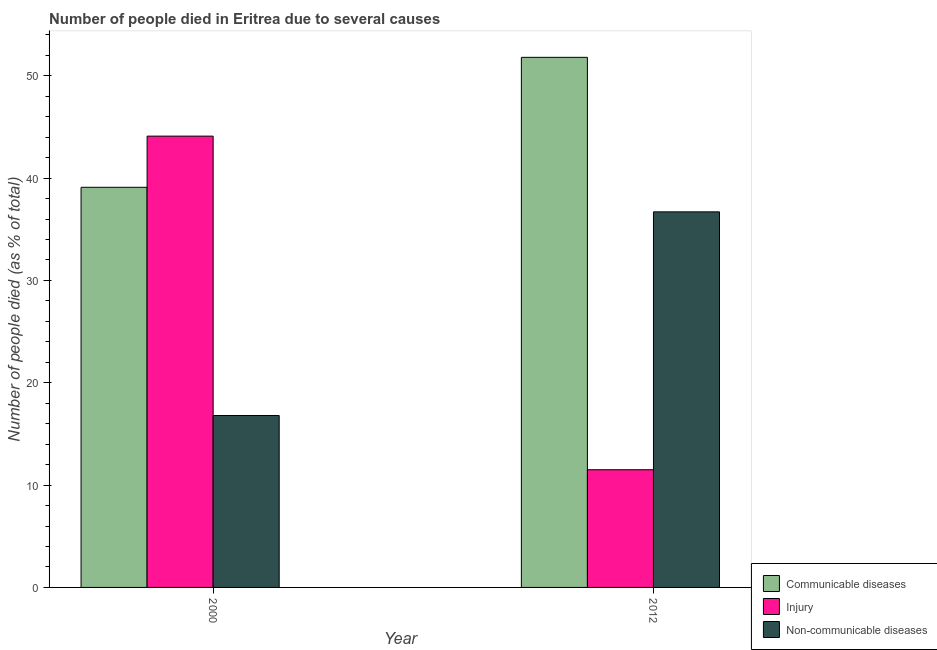How many bars are there on the 2nd tick from the right?
Provide a short and direct response. 3. Across all years, what is the maximum number of people who dies of non-communicable diseases?
Make the answer very short. 36.7. In which year was the number of people who dies of non-communicable diseases maximum?
Provide a short and direct response. 2012. In which year was the number of people who died of injury minimum?
Your answer should be compact. 2012. What is the total number of people who dies of non-communicable diseases in the graph?
Your response must be concise. 53.5. What is the difference between the number of people who died of communicable diseases in 2000 and that in 2012?
Your response must be concise. -12.7. What is the difference between the number of people who dies of non-communicable diseases in 2000 and the number of people who died of injury in 2012?
Your answer should be compact. -19.9. What is the average number of people who died of communicable diseases per year?
Keep it short and to the point. 45.45. In the year 2000, what is the difference between the number of people who died of injury and number of people who dies of non-communicable diseases?
Your answer should be very brief. 0. What is the ratio of the number of people who died of communicable diseases in 2000 to that in 2012?
Your response must be concise. 0.75. Is the number of people who dies of non-communicable diseases in 2000 less than that in 2012?
Your response must be concise. Yes. In how many years, is the number of people who died of injury greater than the average number of people who died of injury taken over all years?
Keep it short and to the point. 1. What does the 2nd bar from the left in 2012 represents?
Your answer should be very brief. Injury. What does the 2nd bar from the right in 2000 represents?
Make the answer very short. Injury. Is it the case that in every year, the sum of the number of people who died of communicable diseases and number of people who died of injury is greater than the number of people who dies of non-communicable diseases?
Give a very brief answer. Yes. How many years are there in the graph?
Provide a succinct answer. 2. What is the difference between two consecutive major ticks on the Y-axis?
Your response must be concise. 10. Does the graph contain grids?
Your answer should be very brief. No. Where does the legend appear in the graph?
Give a very brief answer. Bottom right. What is the title of the graph?
Ensure brevity in your answer.  Number of people died in Eritrea due to several causes. What is the label or title of the Y-axis?
Make the answer very short. Number of people died (as % of total). What is the Number of people died (as % of total) of Communicable diseases in 2000?
Ensure brevity in your answer.  39.1. What is the Number of people died (as % of total) in Injury in 2000?
Your answer should be compact. 44.1. What is the Number of people died (as % of total) of Non-communicable diseases in 2000?
Ensure brevity in your answer.  16.8. What is the Number of people died (as % of total) of Communicable diseases in 2012?
Make the answer very short. 51.8. What is the Number of people died (as % of total) in Injury in 2012?
Provide a succinct answer. 11.5. What is the Number of people died (as % of total) of Non-communicable diseases in 2012?
Keep it short and to the point. 36.7. Across all years, what is the maximum Number of people died (as % of total) in Communicable diseases?
Offer a terse response. 51.8. Across all years, what is the maximum Number of people died (as % of total) of Injury?
Keep it short and to the point. 44.1. Across all years, what is the maximum Number of people died (as % of total) in Non-communicable diseases?
Your answer should be very brief. 36.7. Across all years, what is the minimum Number of people died (as % of total) in Communicable diseases?
Your response must be concise. 39.1. Across all years, what is the minimum Number of people died (as % of total) of Injury?
Your answer should be very brief. 11.5. Across all years, what is the minimum Number of people died (as % of total) in Non-communicable diseases?
Your answer should be compact. 16.8. What is the total Number of people died (as % of total) in Communicable diseases in the graph?
Your answer should be compact. 90.9. What is the total Number of people died (as % of total) in Injury in the graph?
Keep it short and to the point. 55.6. What is the total Number of people died (as % of total) of Non-communicable diseases in the graph?
Offer a terse response. 53.5. What is the difference between the Number of people died (as % of total) in Communicable diseases in 2000 and that in 2012?
Your response must be concise. -12.7. What is the difference between the Number of people died (as % of total) in Injury in 2000 and that in 2012?
Provide a short and direct response. 32.6. What is the difference between the Number of people died (as % of total) of Non-communicable diseases in 2000 and that in 2012?
Your response must be concise. -19.9. What is the difference between the Number of people died (as % of total) in Communicable diseases in 2000 and the Number of people died (as % of total) in Injury in 2012?
Provide a succinct answer. 27.6. What is the average Number of people died (as % of total) of Communicable diseases per year?
Your answer should be very brief. 45.45. What is the average Number of people died (as % of total) of Injury per year?
Make the answer very short. 27.8. What is the average Number of people died (as % of total) of Non-communicable diseases per year?
Ensure brevity in your answer.  26.75. In the year 2000, what is the difference between the Number of people died (as % of total) of Communicable diseases and Number of people died (as % of total) of Non-communicable diseases?
Give a very brief answer. 22.3. In the year 2000, what is the difference between the Number of people died (as % of total) of Injury and Number of people died (as % of total) of Non-communicable diseases?
Ensure brevity in your answer.  27.3. In the year 2012, what is the difference between the Number of people died (as % of total) of Communicable diseases and Number of people died (as % of total) of Injury?
Provide a succinct answer. 40.3. In the year 2012, what is the difference between the Number of people died (as % of total) in Communicable diseases and Number of people died (as % of total) in Non-communicable diseases?
Offer a terse response. 15.1. In the year 2012, what is the difference between the Number of people died (as % of total) of Injury and Number of people died (as % of total) of Non-communicable diseases?
Provide a succinct answer. -25.2. What is the ratio of the Number of people died (as % of total) in Communicable diseases in 2000 to that in 2012?
Your answer should be compact. 0.75. What is the ratio of the Number of people died (as % of total) in Injury in 2000 to that in 2012?
Keep it short and to the point. 3.83. What is the ratio of the Number of people died (as % of total) in Non-communicable diseases in 2000 to that in 2012?
Offer a very short reply. 0.46. What is the difference between the highest and the second highest Number of people died (as % of total) of Injury?
Your answer should be very brief. 32.6. What is the difference between the highest and the second highest Number of people died (as % of total) of Non-communicable diseases?
Provide a succinct answer. 19.9. What is the difference between the highest and the lowest Number of people died (as % of total) in Injury?
Offer a terse response. 32.6. What is the difference between the highest and the lowest Number of people died (as % of total) of Non-communicable diseases?
Your answer should be very brief. 19.9. 